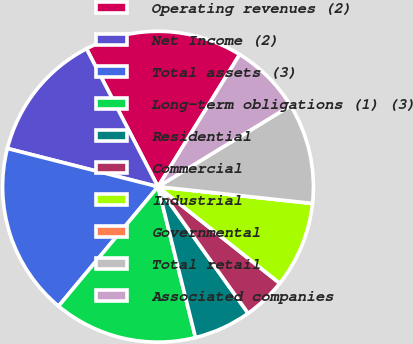Convert chart to OTSL. <chart><loc_0><loc_0><loc_500><loc_500><pie_chart><fcel>Operating revenues (2)<fcel>Net Income (2)<fcel>Total assets (3)<fcel>Long-term obligations (1) (3)<fcel>Residential<fcel>Commercial<fcel>Industrial<fcel>Governmental<fcel>Total retail<fcel>Associated companies<nl><fcel>16.42%<fcel>13.43%<fcel>17.91%<fcel>14.93%<fcel>5.97%<fcel>4.48%<fcel>8.96%<fcel>0.0%<fcel>10.45%<fcel>7.46%<nl></chart> 